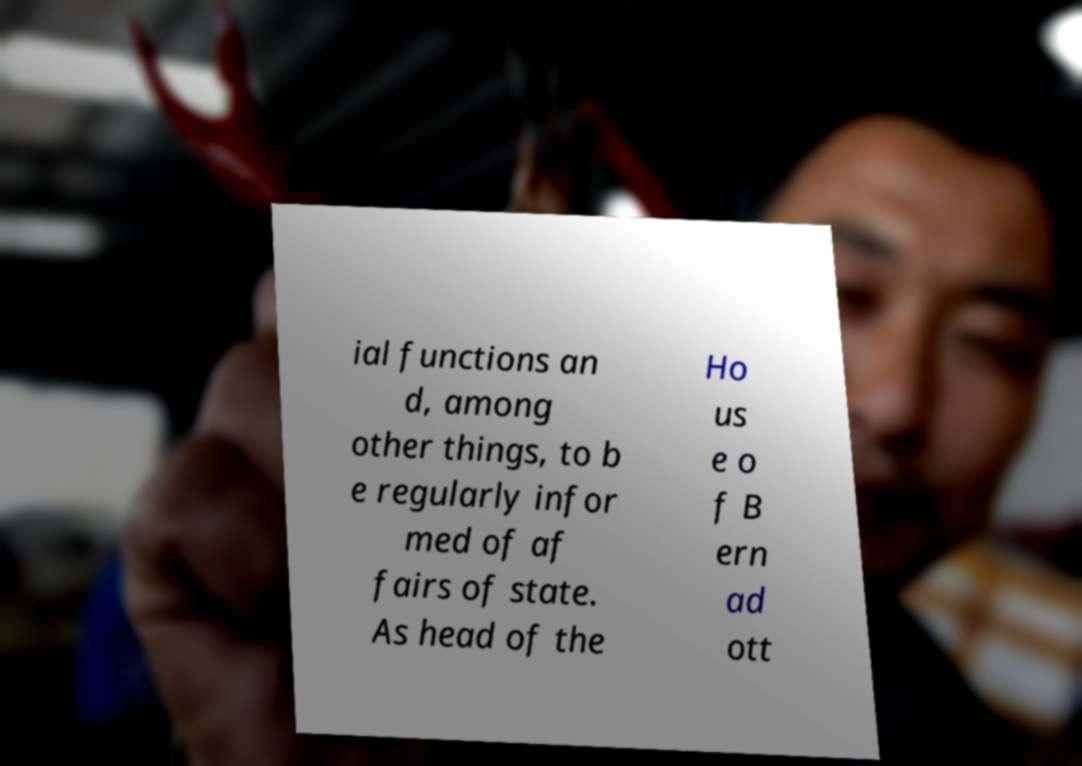Could you assist in decoding the text presented in this image and type it out clearly? ial functions an d, among other things, to b e regularly infor med of af fairs of state. As head of the Ho us e o f B ern ad ott 